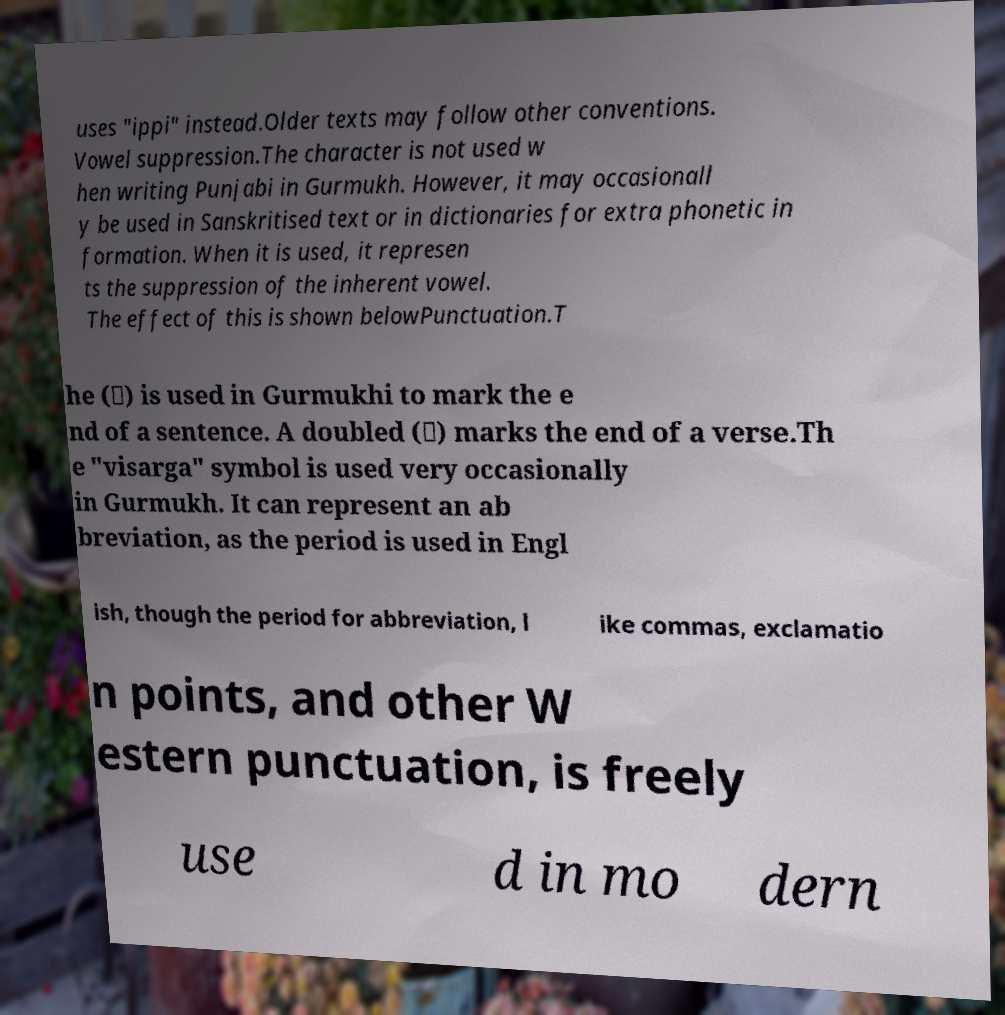There's text embedded in this image that I need extracted. Can you transcribe it verbatim? uses "ippi" instead.Older texts may follow other conventions. Vowel suppression.The character is not used w hen writing Punjabi in Gurmukh. However, it may occasionall y be used in Sanskritised text or in dictionaries for extra phonetic in formation. When it is used, it represen ts the suppression of the inherent vowel. The effect of this is shown belowPunctuation.T he (।) is used in Gurmukhi to mark the e nd of a sentence. A doubled (॥) marks the end of a verse.Th e "visarga" symbol is used very occasionally in Gurmukh. It can represent an ab breviation, as the period is used in Engl ish, though the period for abbreviation, l ike commas, exclamatio n points, and other W estern punctuation, is freely use d in mo dern 